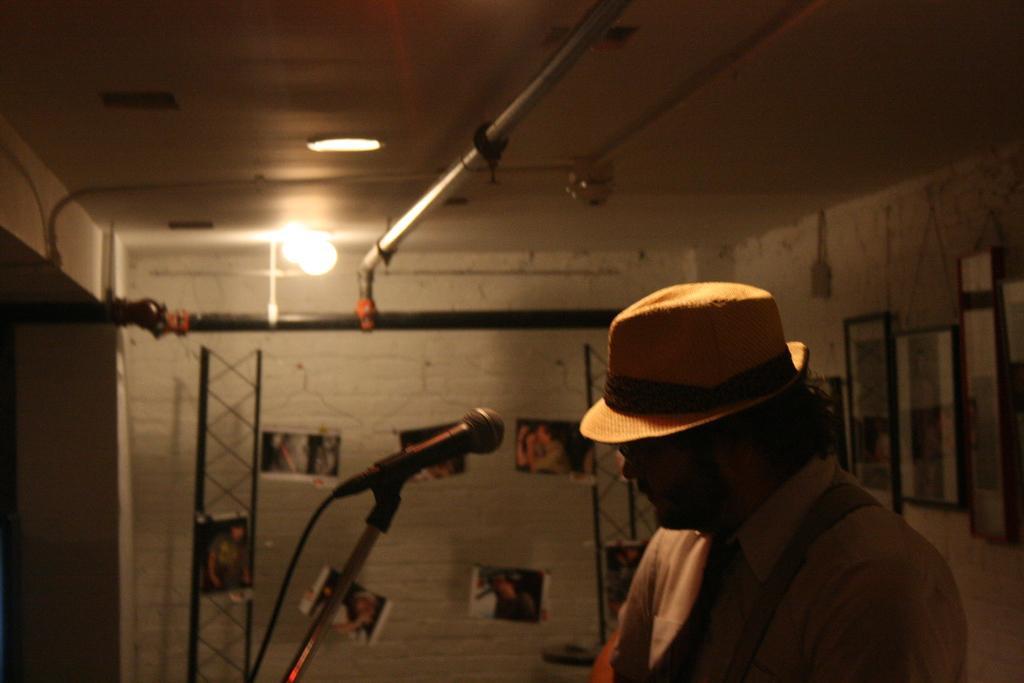Can you describe this image briefly? In this picture I can see a person with a hat, there is a mike with a mike stand, there are lights and some other objects, and in the background there are photo frames and photos attached to the walls. 